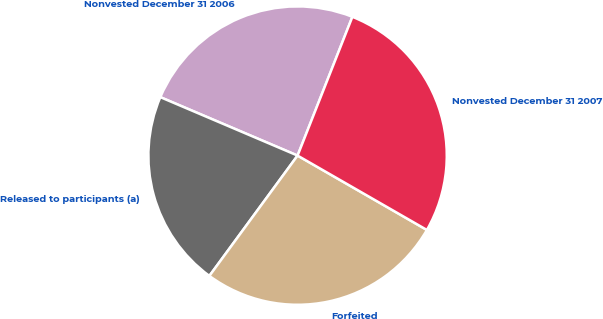Convert chart to OTSL. <chart><loc_0><loc_0><loc_500><loc_500><pie_chart><fcel>Nonvested December 31 2006<fcel>Released to participants (a)<fcel>Forfeited<fcel>Nonvested December 31 2007<nl><fcel>24.58%<fcel>21.34%<fcel>26.76%<fcel>27.32%<nl></chart> 